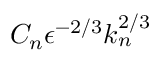Convert formula to latex. <formula><loc_0><loc_0><loc_500><loc_500>C _ { n } \epsilon ^ { - 2 / 3 } k _ { n } ^ { 2 / 3 }</formula> 